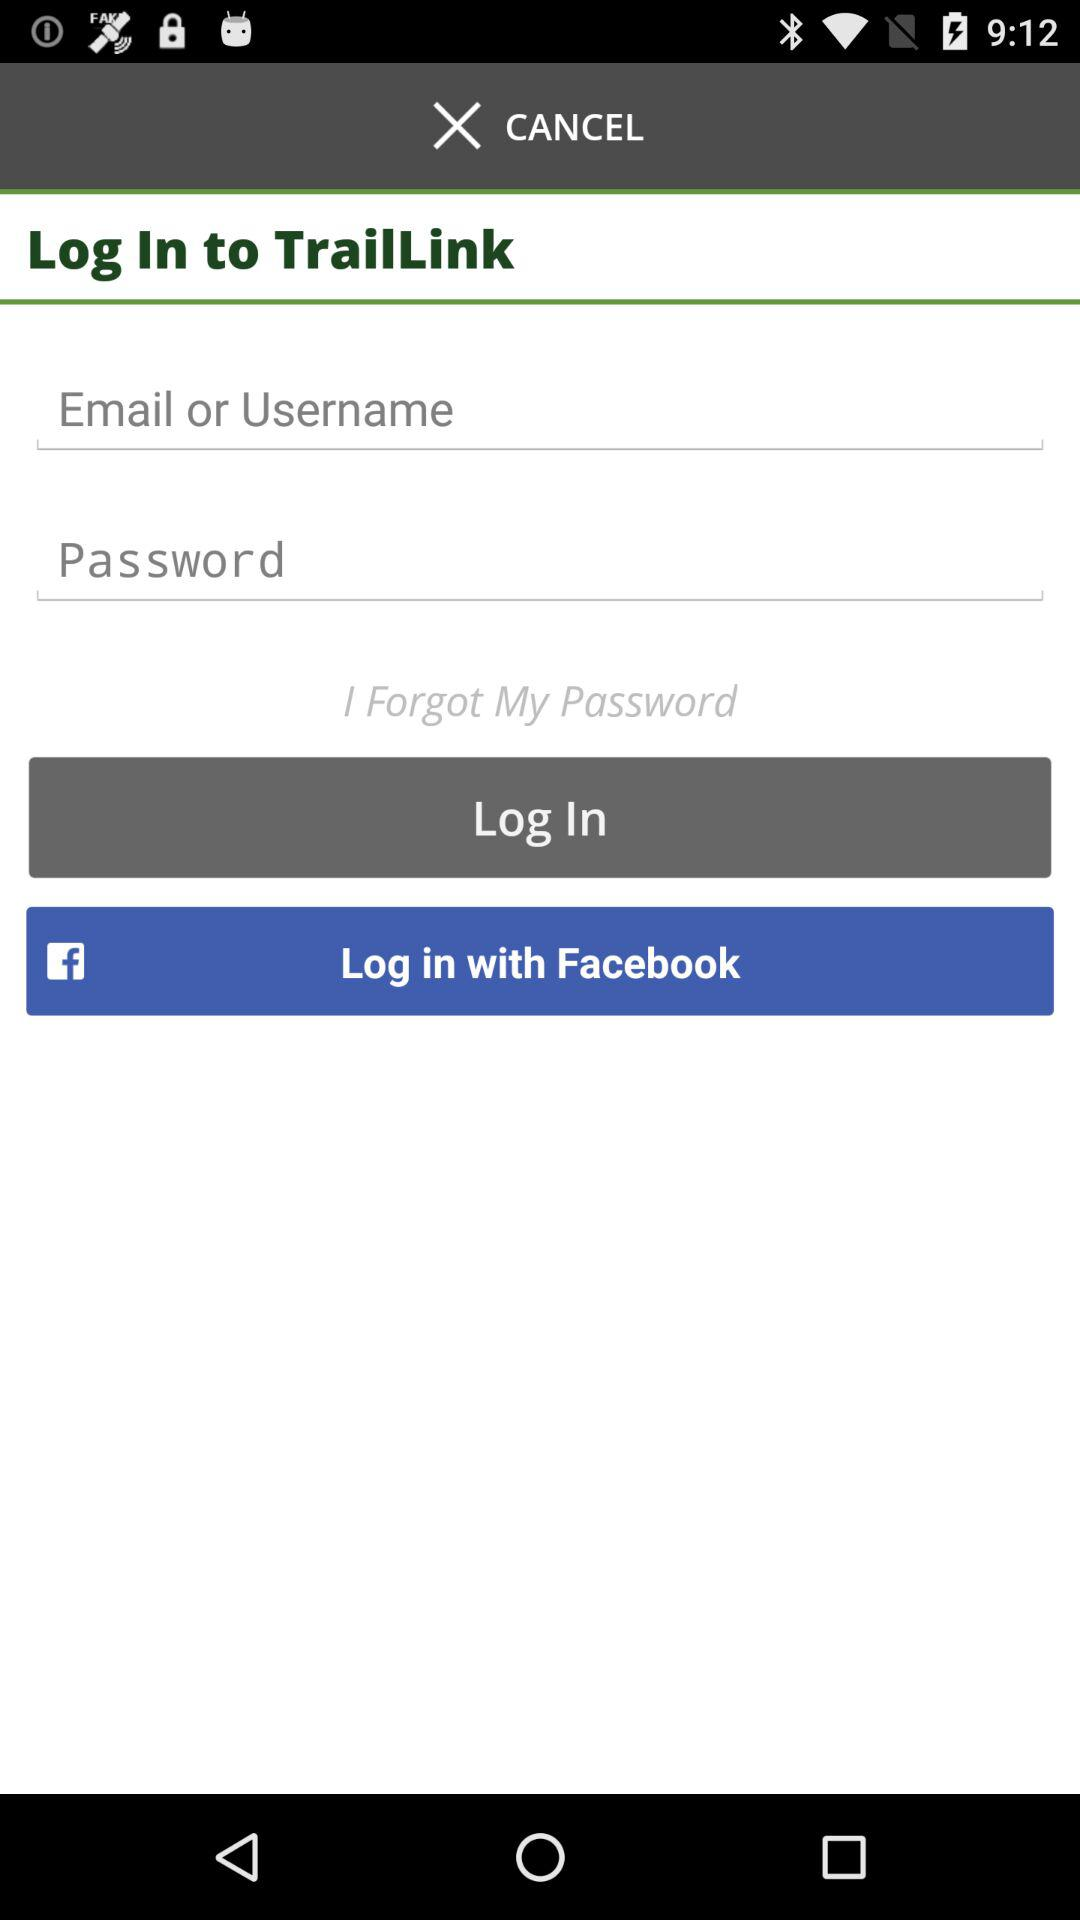What are the different options available for logging in? The different options available for logging in are "Email or Username" and "Facebook". 